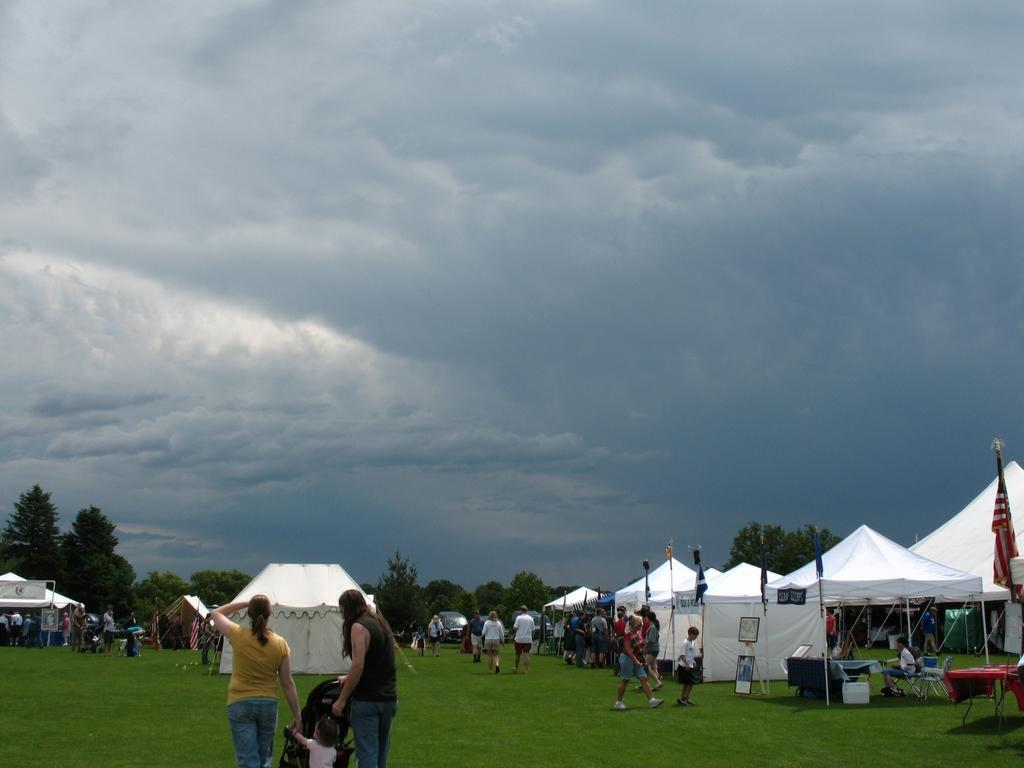How would you summarize this image in a sentence or two? In this picture I can see the grass, on which there are number of people, tents and few flags. On the right side of this picture I can see the tables and chairs. In the background I can see few cars, number of trees and the cloudy sky. 